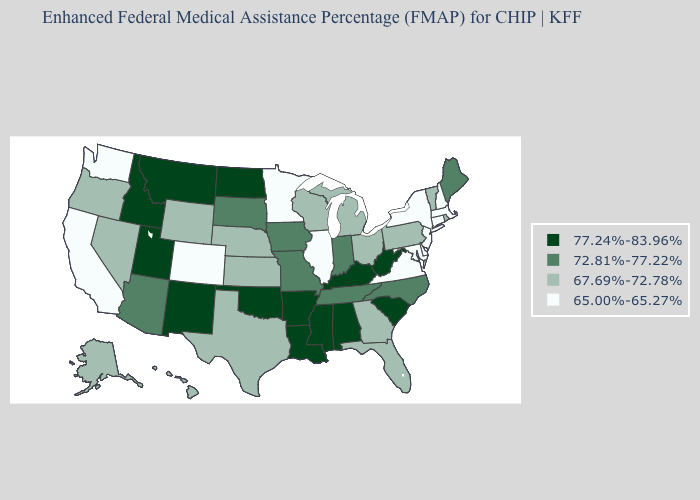Does the map have missing data?
Give a very brief answer. No. What is the lowest value in the Northeast?
Give a very brief answer. 65.00%-65.27%. Name the states that have a value in the range 65.00%-65.27%?
Keep it brief. California, Colorado, Connecticut, Delaware, Illinois, Maryland, Massachusetts, Minnesota, New Hampshire, New Jersey, New York, Virginia, Washington. Name the states that have a value in the range 65.00%-65.27%?
Answer briefly. California, Colorado, Connecticut, Delaware, Illinois, Maryland, Massachusetts, Minnesota, New Hampshire, New Jersey, New York, Virginia, Washington. Does Michigan have a higher value than North Carolina?
Be succinct. No. What is the value of Tennessee?
Keep it brief. 72.81%-77.22%. What is the highest value in the USA?
Be succinct. 77.24%-83.96%. Which states hav the highest value in the West?
Concise answer only. Idaho, Montana, New Mexico, Utah. What is the value of Massachusetts?
Concise answer only. 65.00%-65.27%. Name the states that have a value in the range 77.24%-83.96%?
Write a very short answer. Alabama, Arkansas, Idaho, Kentucky, Louisiana, Mississippi, Montana, New Mexico, North Dakota, Oklahoma, South Carolina, Utah, West Virginia. Name the states that have a value in the range 67.69%-72.78%?
Give a very brief answer. Alaska, Florida, Georgia, Hawaii, Kansas, Michigan, Nebraska, Nevada, Ohio, Oregon, Pennsylvania, Rhode Island, Texas, Vermont, Wisconsin, Wyoming. Name the states that have a value in the range 65.00%-65.27%?
Quick response, please. California, Colorado, Connecticut, Delaware, Illinois, Maryland, Massachusetts, Minnesota, New Hampshire, New Jersey, New York, Virginia, Washington. Does the first symbol in the legend represent the smallest category?
Keep it brief. No. Name the states that have a value in the range 77.24%-83.96%?
Write a very short answer. Alabama, Arkansas, Idaho, Kentucky, Louisiana, Mississippi, Montana, New Mexico, North Dakota, Oklahoma, South Carolina, Utah, West Virginia. What is the value of Delaware?
Keep it brief. 65.00%-65.27%. 